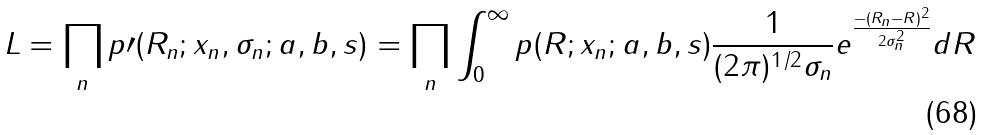Convert formula to latex. <formula><loc_0><loc_0><loc_500><loc_500>L = \prod _ { n } p \prime ( R _ { n } ; x _ { n } , \sigma _ { n } ; a , b , s ) = \prod _ { n } \int _ { 0 } ^ { \infty } p ( R ; x _ { n } ; a , b , s ) \frac { 1 } { ( 2 \pi ) ^ { 1 / 2 } \sigma _ { n } } e ^ { \frac { - ( R _ { n } - R ) ^ { 2 } } { 2 \sigma _ { n } ^ { 2 } } } d R</formula> 